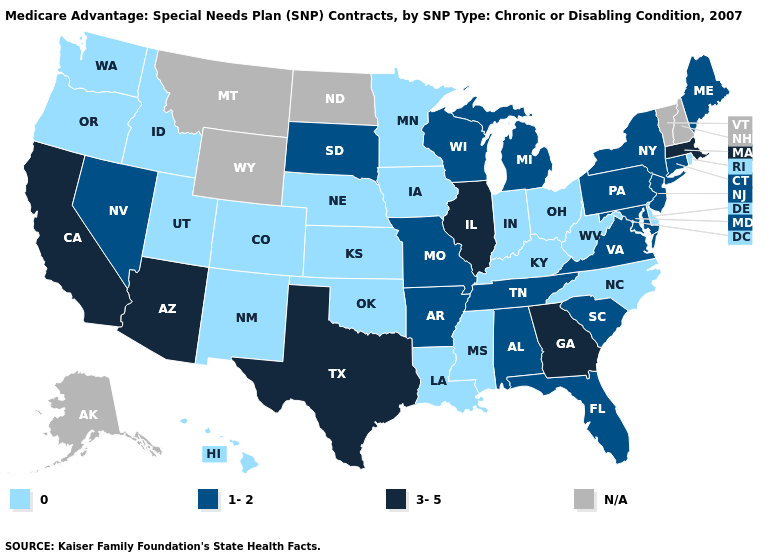Does Virginia have the lowest value in the USA?
Be succinct. No. Does Utah have the lowest value in the West?
Write a very short answer. Yes. What is the highest value in the South ?
Be succinct. 3-5. What is the value of New York?
Quick response, please. 1-2. Name the states that have a value in the range 1-2?
Write a very short answer. Alabama, Arkansas, Connecticut, Florida, Maryland, Maine, Michigan, Missouri, New Jersey, Nevada, New York, Pennsylvania, South Carolina, South Dakota, Tennessee, Virginia, Wisconsin. Does the map have missing data?
Concise answer only. Yes. Among the states that border New Hampshire , does Maine have the lowest value?
Answer briefly. Yes. Name the states that have a value in the range 0?
Concise answer only. Colorado, Delaware, Hawaii, Iowa, Idaho, Indiana, Kansas, Kentucky, Louisiana, Minnesota, Mississippi, North Carolina, Nebraska, New Mexico, Ohio, Oklahoma, Oregon, Rhode Island, Utah, Washington, West Virginia. How many symbols are there in the legend?
Write a very short answer. 4. How many symbols are there in the legend?
Keep it brief. 4. Name the states that have a value in the range 3-5?
Concise answer only. Arizona, California, Georgia, Illinois, Massachusetts, Texas. What is the lowest value in the USA?
Keep it brief. 0. Among the states that border Vermont , which have the lowest value?
Concise answer only. New York. 